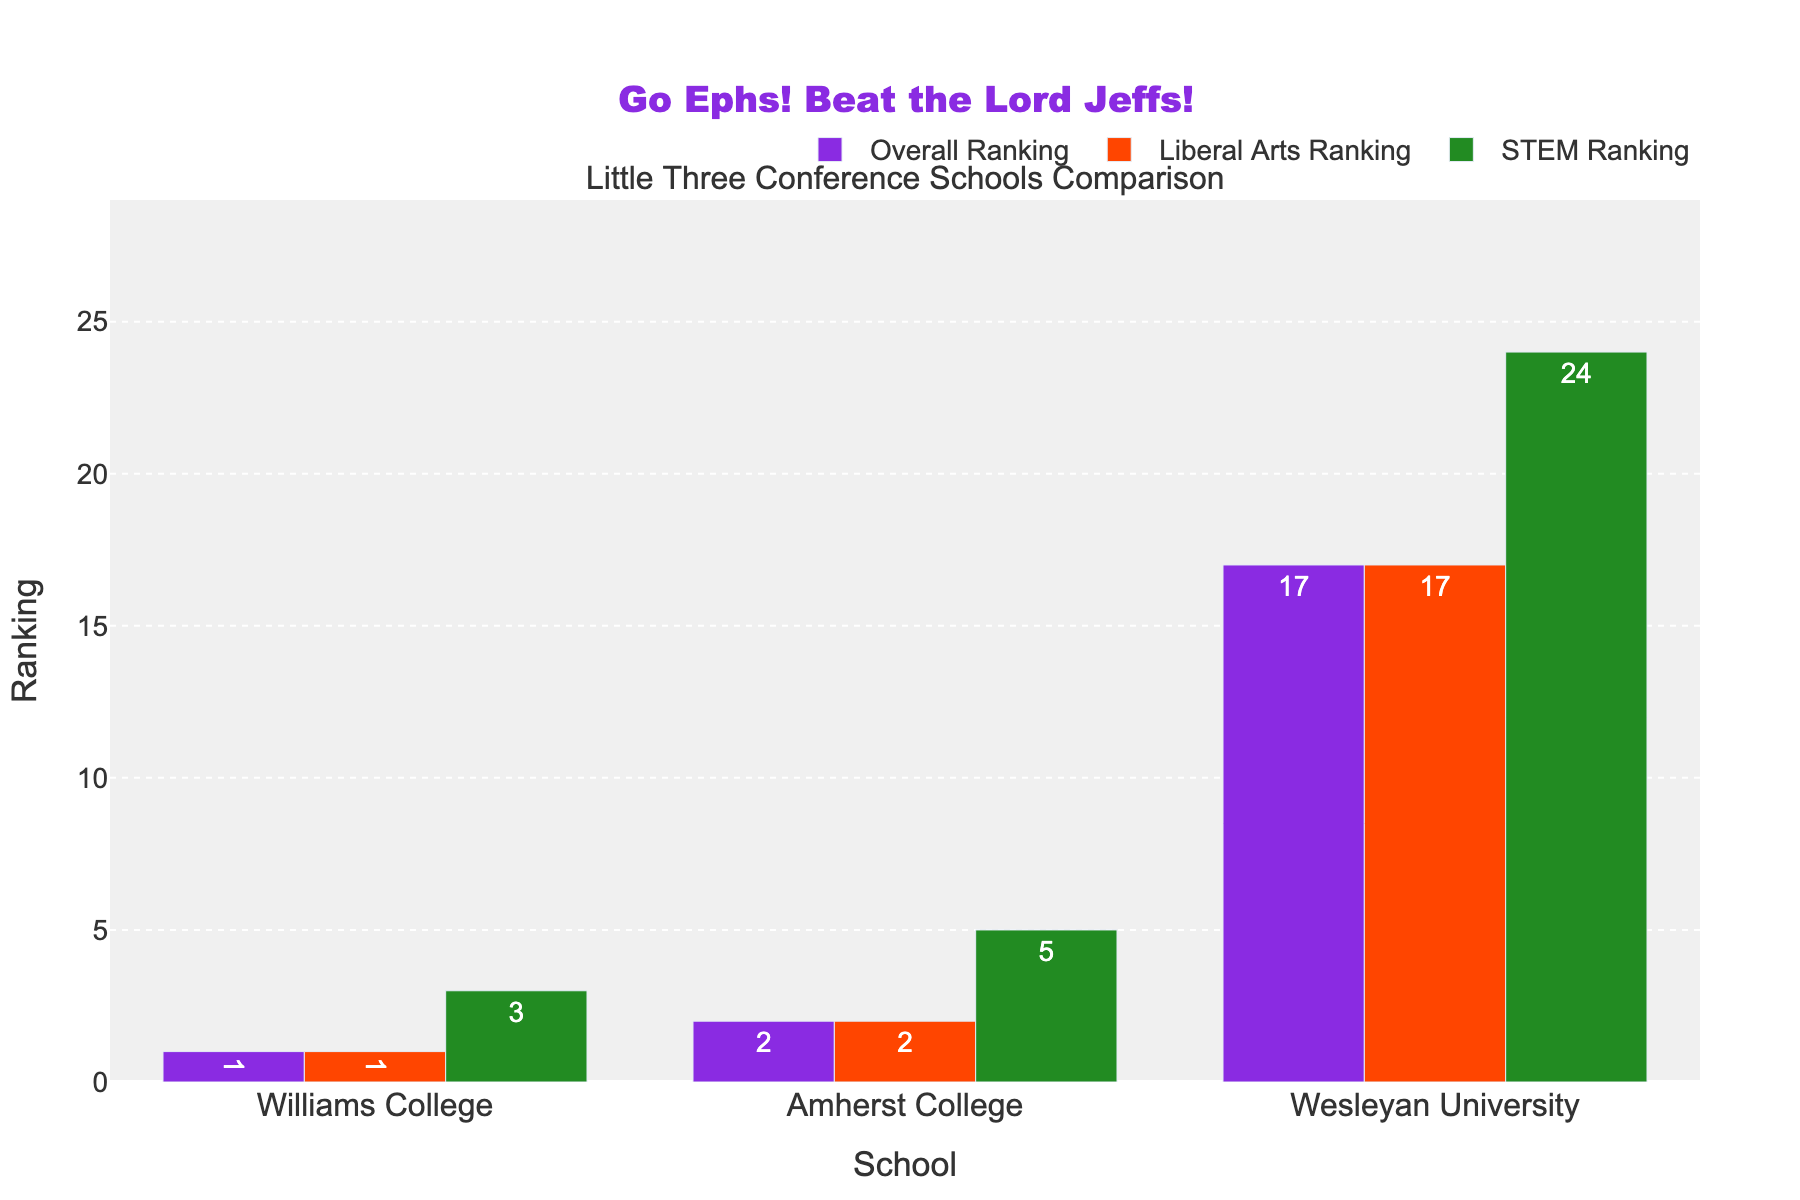Which school has the lowest overall ranking? We compare the overall rankings of the three schools: Williams College (1), Amherst College (2), and Wesleyan University (17). The lowest ranking is the one with the highest numerical value.
Answer: Wesleyan University Which school has the highest STEM ranking? We compare the STEM rankings of the three schools: Williams College (3), Amherst College (5), and Wesleyan University (24). The highest ranking is the one with the lowest numerical value.
Answer: Williams College Which ranking category has the smallest difference between Amherst College and Williams College? We look at the differences in the rankings between Amherst College and Williams College across three categories: Overall (2-1=1), Liberal Arts (2-1=1), and STEM (5-3=2). The smallest difference is in Overall and Liberal Arts, both having a difference of 1.
Answer: Overall and Liberal Arts What is the average Liberal Arts ranking of the three schools? We sum up the Liberal Arts rankings of Williams College (1), Amherst College (2), and Wesleyan University (17). The sum is 1 + 2 + 17 = 20. The average is the sum divided by the number of schools, so 20 / 3 ≈ 6.67.
Answer: ~6.67 Which school contributes the most to the difference in STEM ranking within the Little Three Conference? To find the maximum contributor, we observe the differences between the schools: Williams College (3), Amherst College (5), and Wesleyan University (24). The largest deviation from the median would be attributed to Wesleyan University because it has the highest discrepancy in value.
Answer: Wesleyan University 